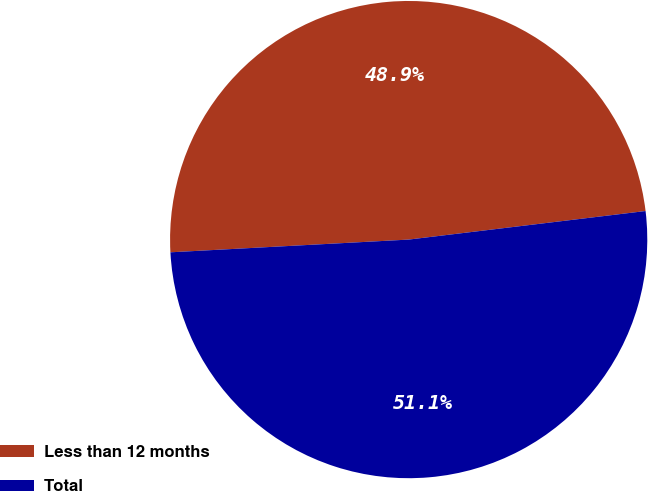Convert chart. <chart><loc_0><loc_0><loc_500><loc_500><pie_chart><fcel>Less than 12 months<fcel>Total<nl><fcel>48.94%<fcel>51.06%<nl></chart> 